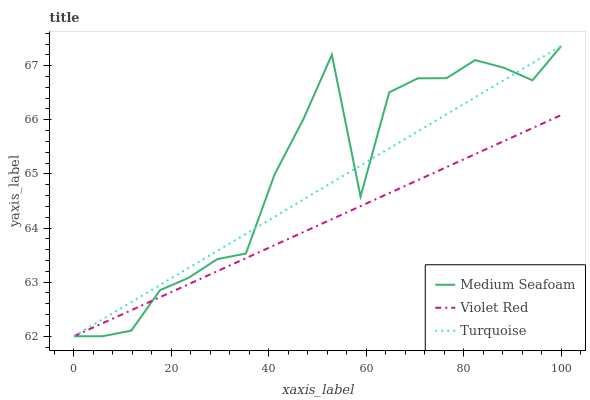Does Violet Red have the minimum area under the curve?
Answer yes or no. Yes. Does Medium Seafoam have the maximum area under the curve?
Answer yes or no. Yes. Does Turquoise have the minimum area under the curve?
Answer yes or no. No. Does Turquoise have the maximum area under the curve?
Answer yes or no. No. Is Turquoise the smoothest?
Answer yes or no. Yes. Is Medium Seafoam the roughest?
Answer yes or no. Yes. Is Medium Seafoam the smoothest?
Answer yes or no. No. Is Turquoise the roughest?
Answer yes or no. No. Does Turquoise have the highest value?
Answer yes or no. Yes. Does Medium Seafoam have the highest value?
Answer yes or no. No. Does Violet Red intersect Medium Seafoam?
Answer yes or no. Yes. Is Violet Red less than Medium Seafoam?
Answer yes or no. No. Is Violet Red greater than Medium Seafoam?
Answer yes or no. No. 